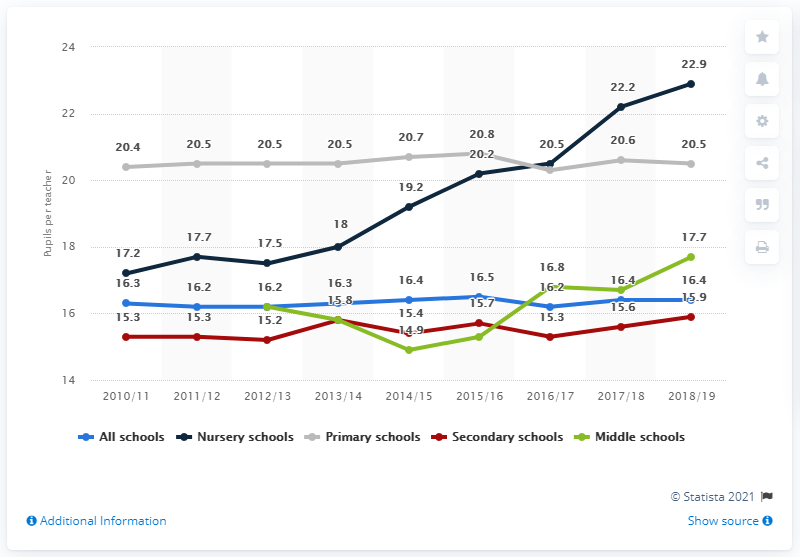Point out several critical features in this image. The sum total of primary schools and secondary schools in the year 2014/15 was 35.6 million. In the 2018/19 academic year, there was an average of 16.4 students for every one teacher in the UK. In the 2018/19 academic year, the highest pupil-to-teacher ratio was observed in nursery schools. In 2018/19, the average number of children per teacher in a nursery school in the UK was 22.9. 